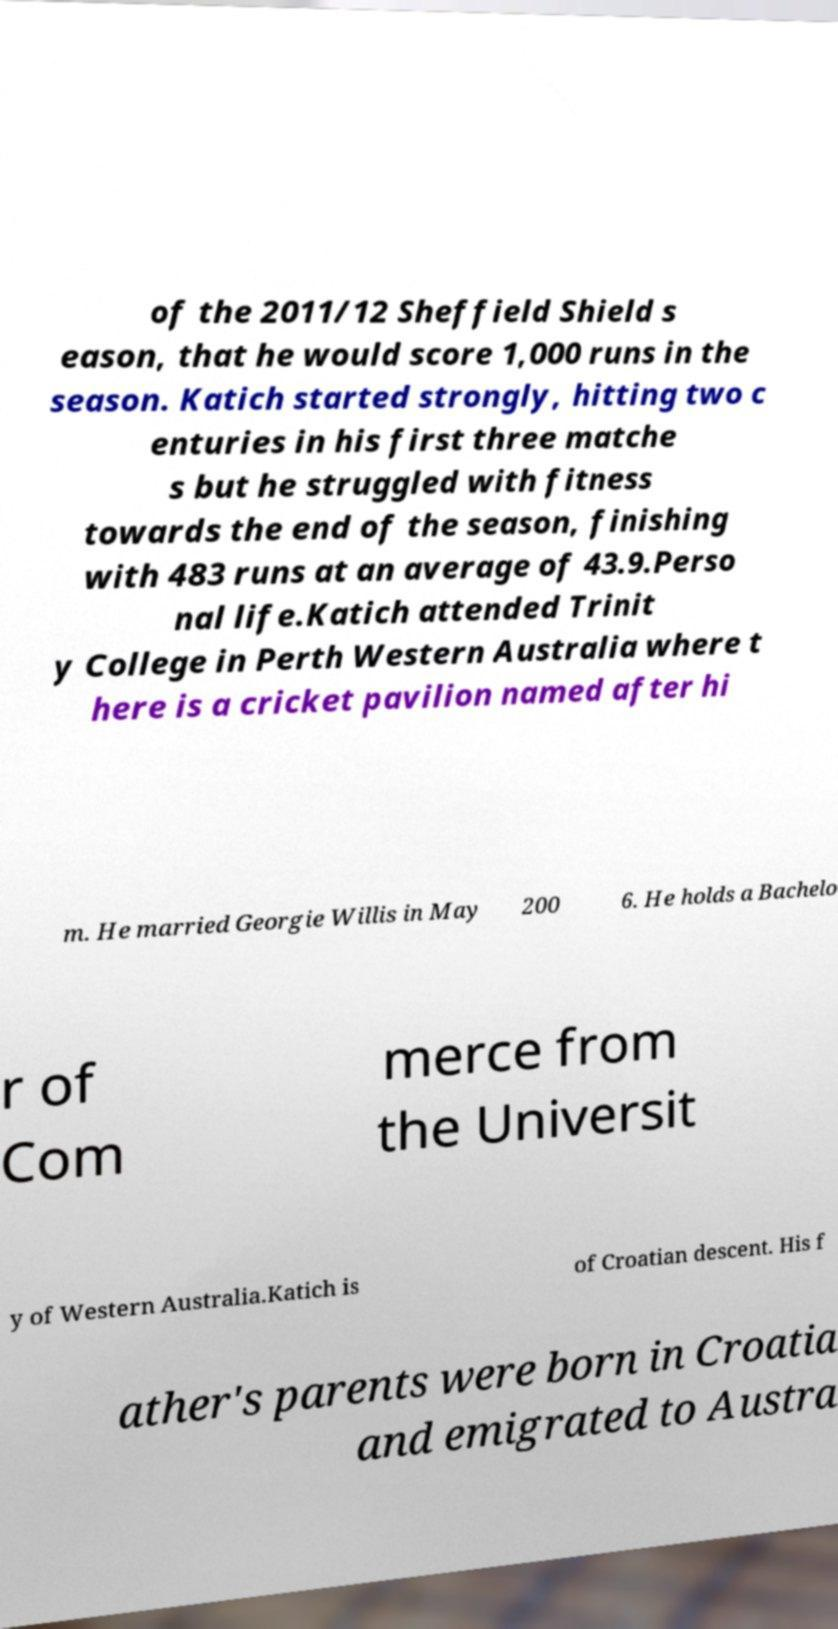Could you assist in decoding the text presented in this image and type it out clearly? of the 2011/12 Sheffield Shield s eason, that he would score 1,000 runs in the season. Katich started strongly, hitting two c enturies in his first three matche s but he struggled with fitness towards the end of the season, finishing with 483 runs at an average of 43.9.Perso nal life.Katich attended Trinit y College in Perth Western Australia where t here is a cricket pavilion named after hi m. He married Georgie Willis in May 200 6. He holds a Bachelo r of Com merce from the Universit y of Western Australia.Katich is of Croatian descent. His f ather's parents were born in Croatia and emigrated to Austra 